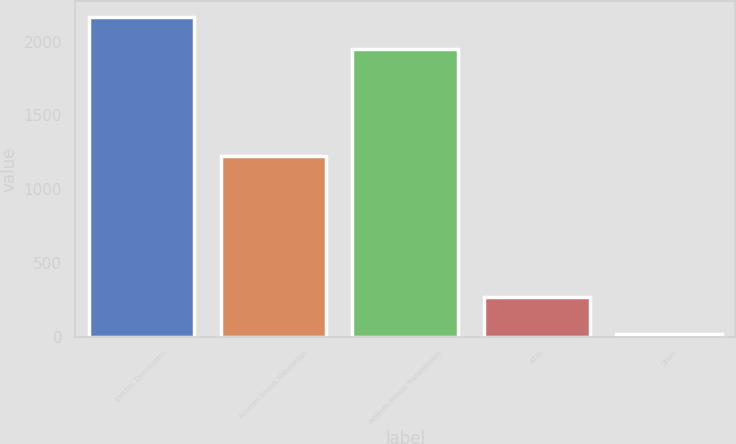Convert chart to OTSL. <chart><loc_0><loc_0><loc_500><loc_500><bar_chart><fcel>Electric Distribution<fcel>Ameren Illinois NaturalGas<fcel>Ameren Illinois Transmission<fcel>ATXI<fcel>Other<nl><fcel>2165<fcel>1225<fcel>1950<fcel>265<fcel>15<nl></chart> 